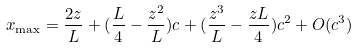Convert formula to latex. <formula><loc_0><loc_0><loc_500><loc_500>x _ { \max } = \frac { 2 z } { L } + ( \frac { L } { 4 } - \frac { z ^ { 2 } } { L } ) c + ( \frac { z ^ { 3 } } { L } - \frac { z L } { 4 } ) c ^ { 2 } + O ( c ^ { 3 } )</formula> 